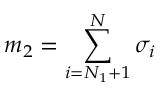<formula> <loc_0><loc_0><loc_500><loc_500>m _ { 2 } = \sum _ { i = N _ { 1 } + 1 } ^ { N } \sigma _ { i }</formula> 